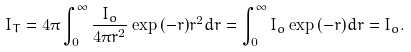Convert formula to latex. <formula><loc_0><loc_0><loc_500><loc_500>I _ { T } = 4 \pi \int _ { 0 } ^ { \infty } \frac { I _ { o } } { 4 \pi r ^ { 2 } } \exp { ( - r ) } r ^ { 2 } d r = \int _ { 0 } ^ { \infty } I _ { o } \exp { ( - r ) } d r = I _ { o } .</formula> 